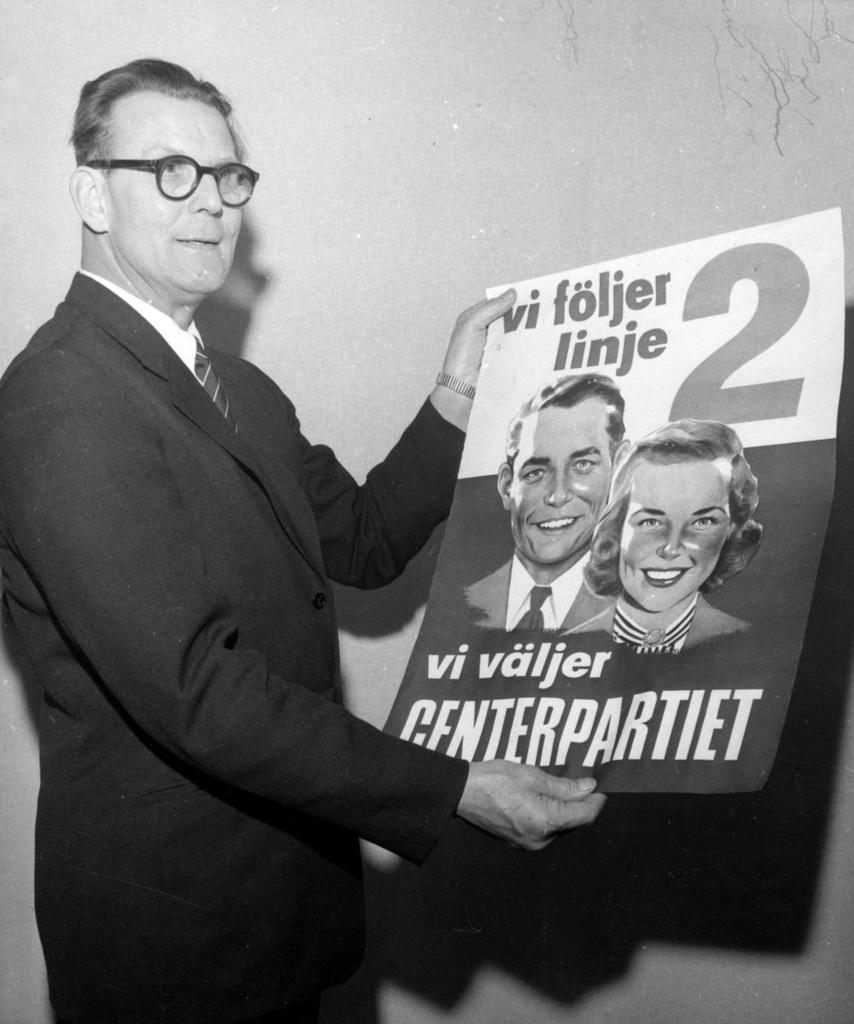How would you summarize this image in a sentence or two? In the picture we can see a black and white photograph of a man standing near the wall and holding a magazine and he is wearing a black color blazer, tie and shirt. 